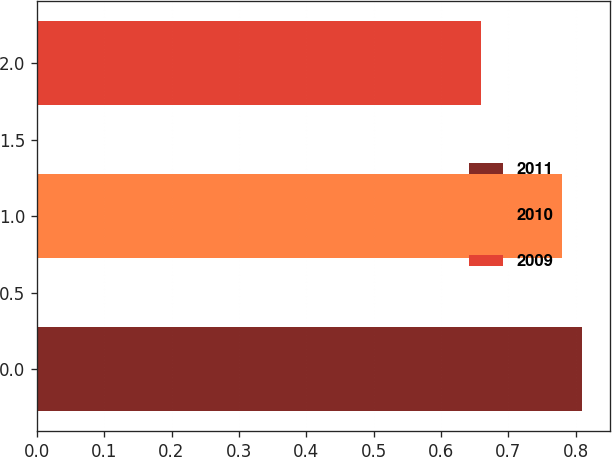Convert chart. <chart><loc_0><loc_0><loc_500><loc_500><bar_chart><fcel>2011<fcel>2010<fcel>2009<nl><fcel>0.81<fcel>0.78<fcel>0.66<nl></chart> 